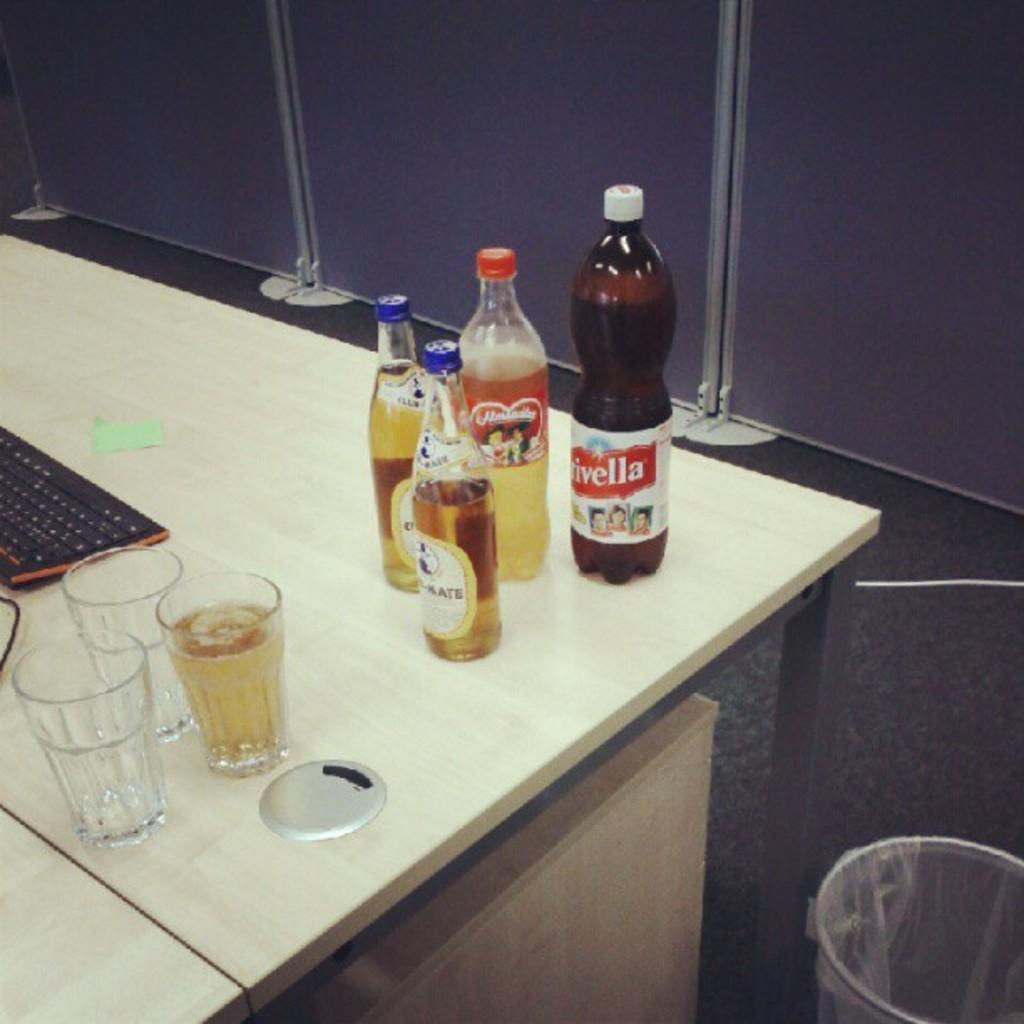How many bottles are on the table in the image? There are four bottles on the table. What else is on the table besides the bottles? There are three glasses and a keyboard on the table. Where is the bin located in relation to the table? The bin is to the right of the table. What type of railway is visible in the image? There is no railway present in the image. What experience does the carpenter have with the keyboard in the image? There is no carpenter or experience mentioned in the image; it only shows bottles, glasses, a keyboard, and a bin. 